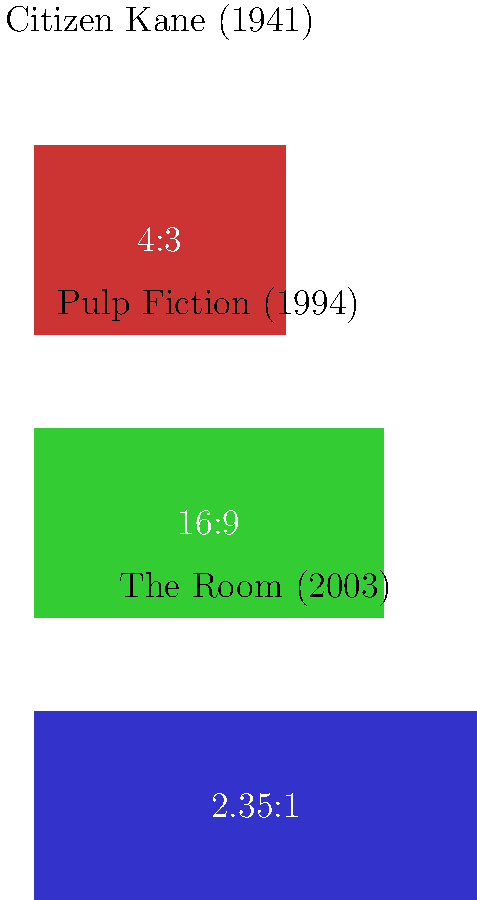In the graphic above, three different aspect ratios are shown, each associated with a famous film. Considering the visual composition and the nature of these films, which aspect ratio would be most suitable for capturing the infamously awkward rooftop scenes in "The Room" while maximizing their unintentional comedic effect? To answer this question, we need to consider the following factors:

1. The aspect ratios shown are:
   - 4:3 (1.33:1) - associated with "Citizen Kane"
   - 16:9 (1.85:1) - associated with "Pulp Fiction"
   - 2.35:1 - associated with "The Room"

2. "The Room" is known for its poor cinematography and awkward compositions, which contribute to its status as a "so bad it's good" cult classic.

3. The rooftop scenes in "The Room" are particularly notorious for their bizarre framing and uncomfortable character positioning.

4. A wider aspect ratio (2.35:1) allows for more horizontal space in the frame, which can:
   a) Emphasize the awkward spacing between characters
   b) Show more of the poorly constructed rooftop set
   c) Highlight the often-criticized green screen effects used in these scenes

5. The wider frame also allows for more negative space, which can make the character interactions seem even more stilted and unnatural.

6. In contrast, a narrower aspect ratio like 4:3 would compress the horizontal space, potentially hiding some of the compositional flaws that make these scenes unintentionally funny.

7. The 16:9 ratio, while wider than 4:3, doesn't offer as much horizontal space as 2.35:1 to fully capture the awkwardness of the scenes.

Therefore, the 2.35:1 aspect ratio, which is actually used in "The Room," is the most suitable for maximizing the unintentional comedic effect of the rooftop scenes by fully showcasing their awkward composition and poor visual effects.
Answer: 2.35:1 